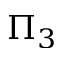Convert formula to latex. <formula><loc_0><loc_0><loc_500><loc_500>\Pi _ { 3 }</formula> 